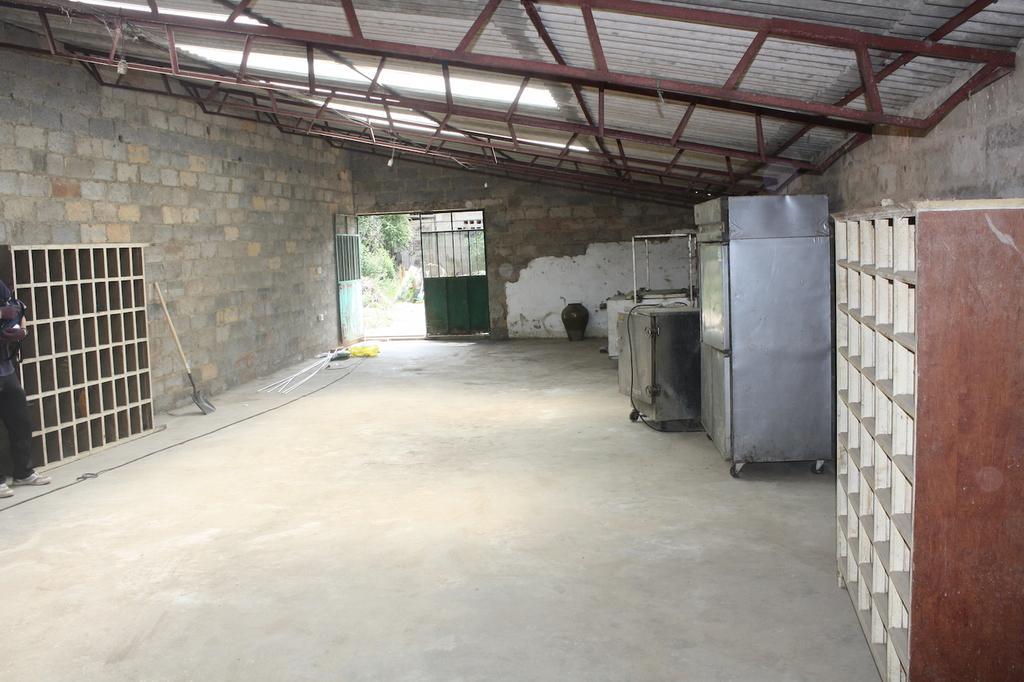Please provide a concise description of this image. In this image I can see cupboards, boxes, some objects on the floor, wall, door, trees, buildings and a rooftop. This image is taken may be in a hall. 